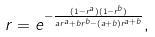Convert formula to latex. <formula><loc_0><loc_0><loc_500><loc_500>r = e ^ { - \frac { ( 1 - r ^ { a } ) ( 1 - r ^ { b } ) } { a r ^ { a } + b r ^ { b } - ( a + b ) r ^ { a + b } } } ,</formula> 